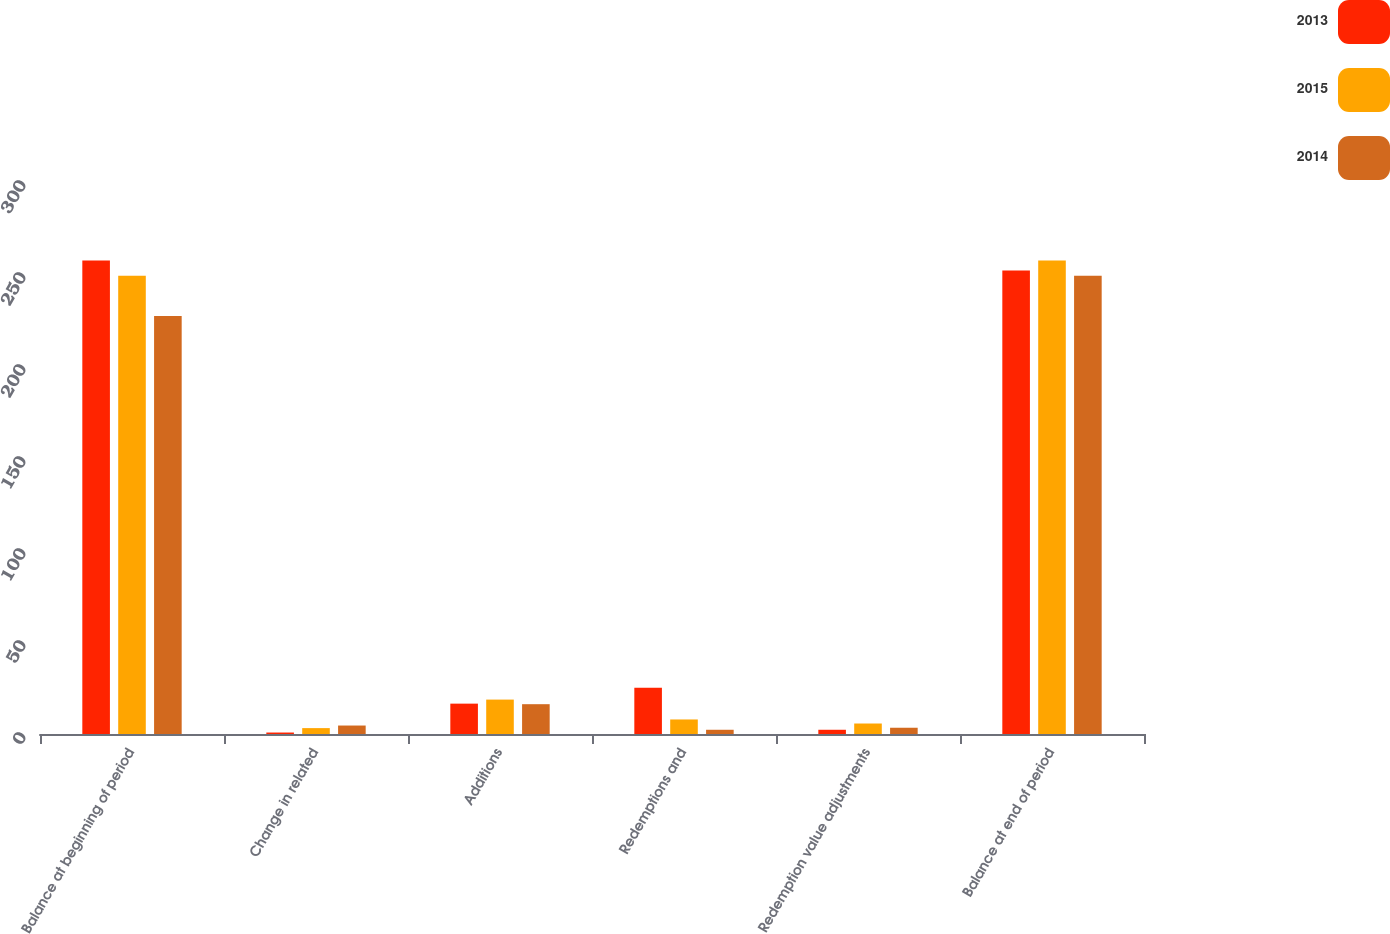Convert chart. <chart><loc_0><loc_0><loc_500><loc_500><stacked_bar_chart><ecel><fcel>Balance at beginning of period<fcel>Change in related<fcel>Additions<fcel>Redemptions and<fcel>Redemption value adjustments<fcel>Balance at end of period<nl><fcel>2013<fcel>257.4<fcel>0.8<fcel>16.5<fcel>25.1<fcel>2.3<fcel>251.9<nl><fcel>2015<fcel>249.1<fcel>3.2<fcel>18.7<fcel>7.9<fcel>5.7<fcel>257.4<nl><fcel>2014<fcel>227.2<fcel>4.6<fcel>16.2<fcel>2.3<fcel>3.4<fcel>249.1<nl></chart> 